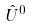<formula> <loc_0><loc_0><loc_500><loc_500>\hat { U } ^ { 0 }</formula> 